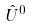<formula> <loc_0><loc_0><loc_500><loc_500>\hat { U } ^ { 0 }</formula> 